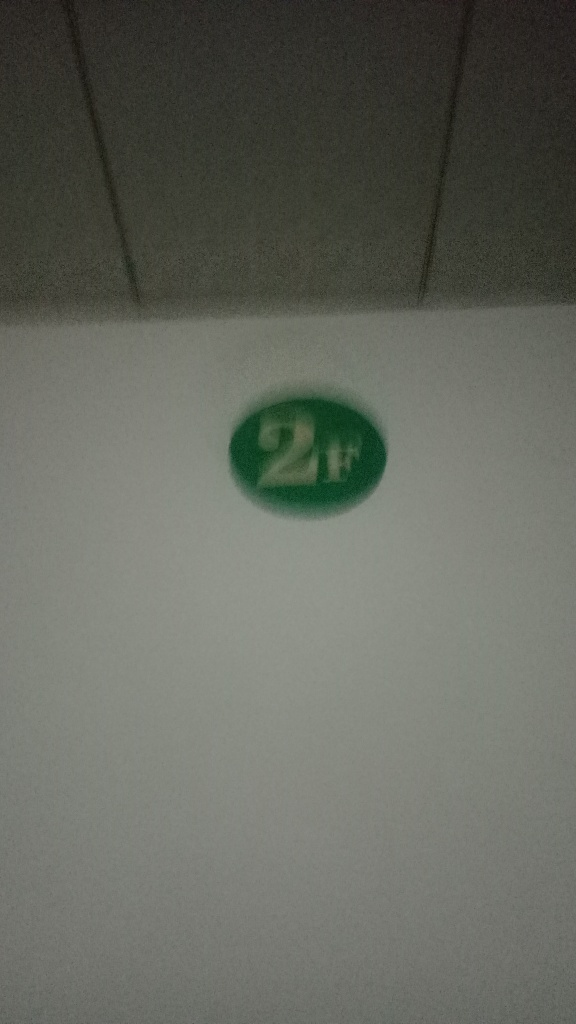Is the image free from any quality issues? The image does exhibit quality issues, such as blurriness and poor lighting, making it difficult to discern finer details. The subject, which appears to be a circular object with a '2H' marking, is not in sharp focus, and the overall composition could be improved for clarity. 